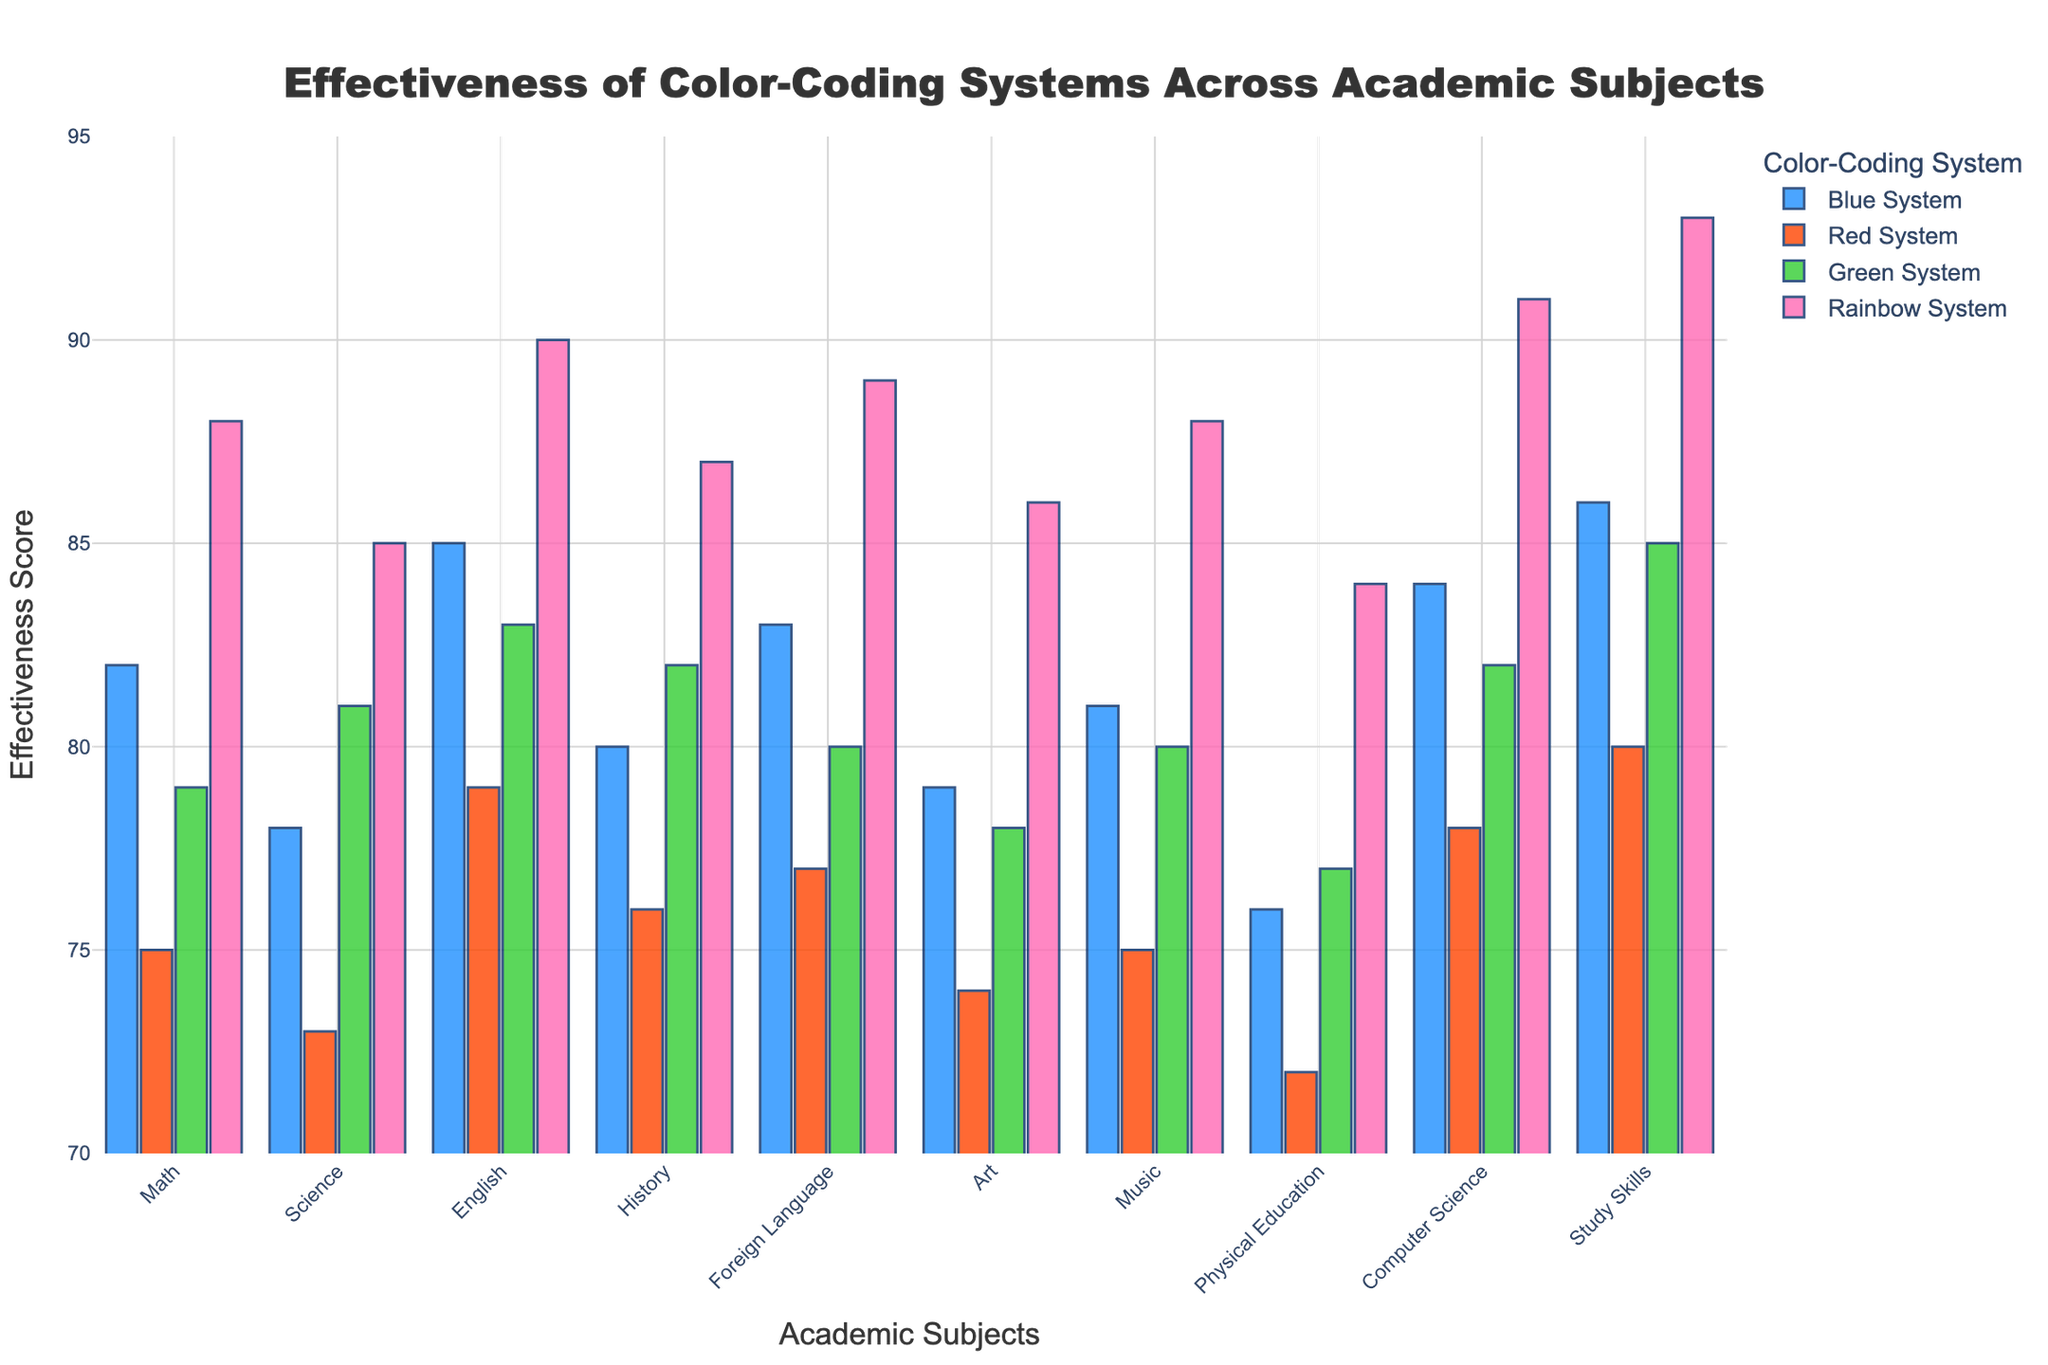What's the most effective color-coding system for improving student productivity in Computer Science? The Rainbow System shows the highest effectiveness score in Computer Science. By comparing the bars for each color-coding system in the Computer Science category, the Rainbow System bar is the tallest, indicating the highest score.
Answer: Rainbow System Which academic subject benefits the least from the Green System? The Physical Education subject shows the lowest effectiveness score for the Green System. By looking at the bars representing the Green System, the bar for Physical Education is the shortest among all subjects.
Answer: Physical Education In which subject does the Red System have the highest effectiveness score? The Red System has the highest effectiveness score in Study Skills. By comparing the heights of the Red System bars for each subject, the bar for Study Skills is the tallest.
Answer: Study Skills What is the difference in effectiveness between the Blue System and the Rainbow System for Math? The effectiveness score for the Blue System in Math is 82, and for the Rainbow System, it is 88. The difference is 88 - 82 = 6.
Answer: 6 What is the average effectiveness score of the Red System across all subjects? Sum the effectiveness scores of the Red System for all subjects: 75 (Math) + 73 (Science) + 79 (English) + 76 (History) + 77 (Foreign Language) + 74 (Art) + 75 (Music) + 72 (Physical Education) + 78 (Computer Science) + 80 (Study Skills) = 759. There are 10 subjects, so the average score is 759 / 10 = 75.9.
Answer: 75.9 Which color-coding system shows the smallest range in effectiveness scores across all academic subjects? To calculate the range, subtract the lowest score from the highest score for each system. 
- Blue System: max 86, min 76, range = 86 - 76 = 10
- Red System: max 80, min 72, range = 80 - 72 = 8
- Green System: max 85, min 77, range = 85 - 77 = 8
- Rainbow System: max 93, min 84, range = 93 - 84 = 9
The Red System and Green System both have the smallest range of 8.
Answer: Red System and Green System Which subject shows the greatest variance in effectiveness scores? To determine variance, we identify the subject with the most varied effectiveness scores.
- Math: 82, 75, 79, 88 (Range: 88 - 75 = 13)
- Science: 78, 73, 81, 85 (Range: 85 - 73 = 12)
- English: 85, 79, 83, 90 (Range: 90 - 79 = 11)
- History: 80, 76, 82, 87 (Range: 87 - 76 = 11)
- Foreign Language: 83, 77, 80, 89 (Range: 89 - 77 = 12)
- Art: 79, 74, 78, 86 (Range: 86 - 74 = 12)
- Music: 81, 75, 80, 88 (Range: 88 - 75 = 13)
- Physical Education: 76, 72, 77, 84 (Range: 84 - 72 = 12)
- Computer Science: 84, 78, 82, 91 (Range: 91 - 78 = 13)
- Study Skills: 86, 80, 85, 93 (Range: 93 - 80 = 13)
Several subjects (Math, Music, Computer Science, Study Skills) all show the maximum range of 13, signifying the greatest variance.
Answer: Math, Music, Computer Science, Study Skills 